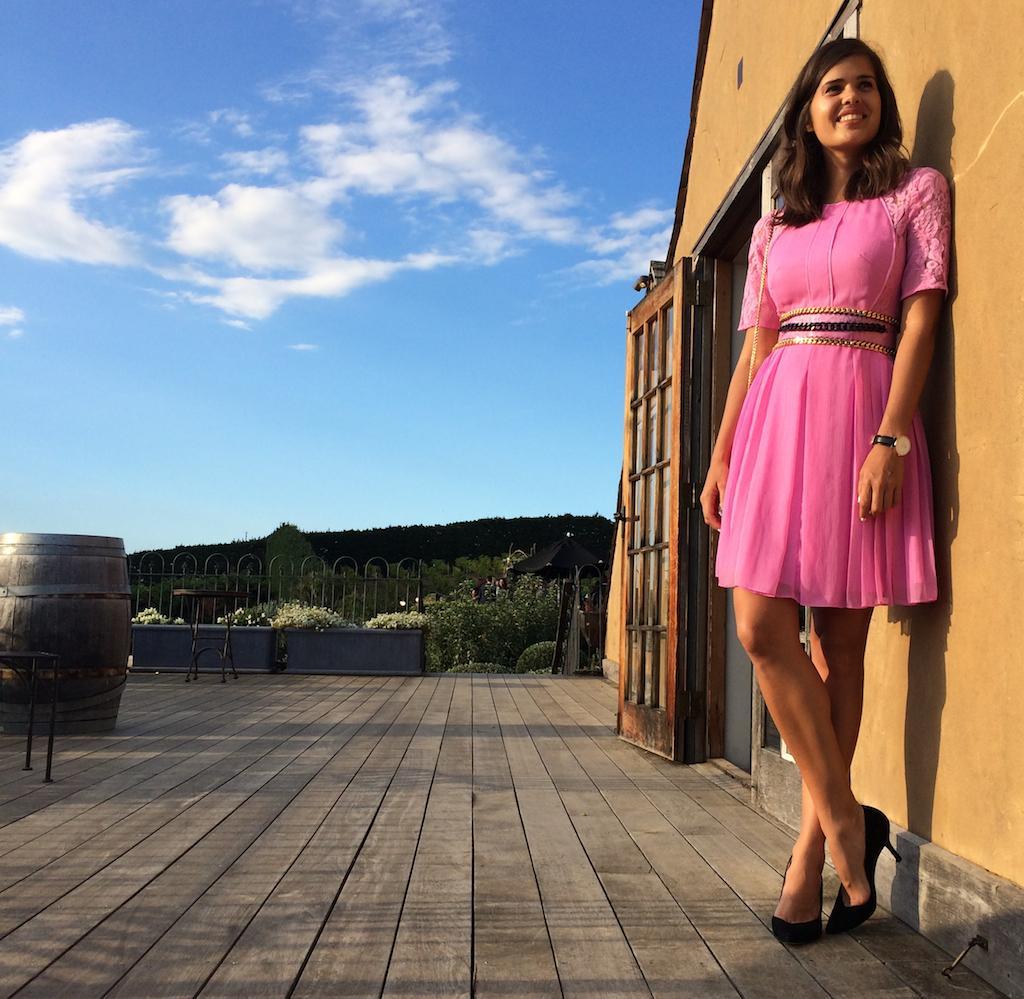Can you describe this image briefly? In the bottom right corner of the image a woman is standing and smiling. Behind her we can see a wall and door. In the middle of the image we can see some chairs, tin and fencing. Behind the fencing we can see some trees. At the top of the image we can see some clouds in the sky. 